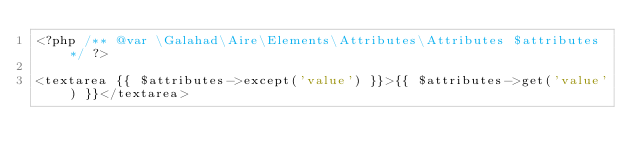<code> <loc_0><loc_0><loc_500><loc_500><_PHP_><?php /** @var \Galahad\Aire\Elements\Attributes\Attributes $attributes */ ?>

<textarea {{ $attributes->except('value') }}>{{ $attributes->get('value') }}</textarea>
</code> 